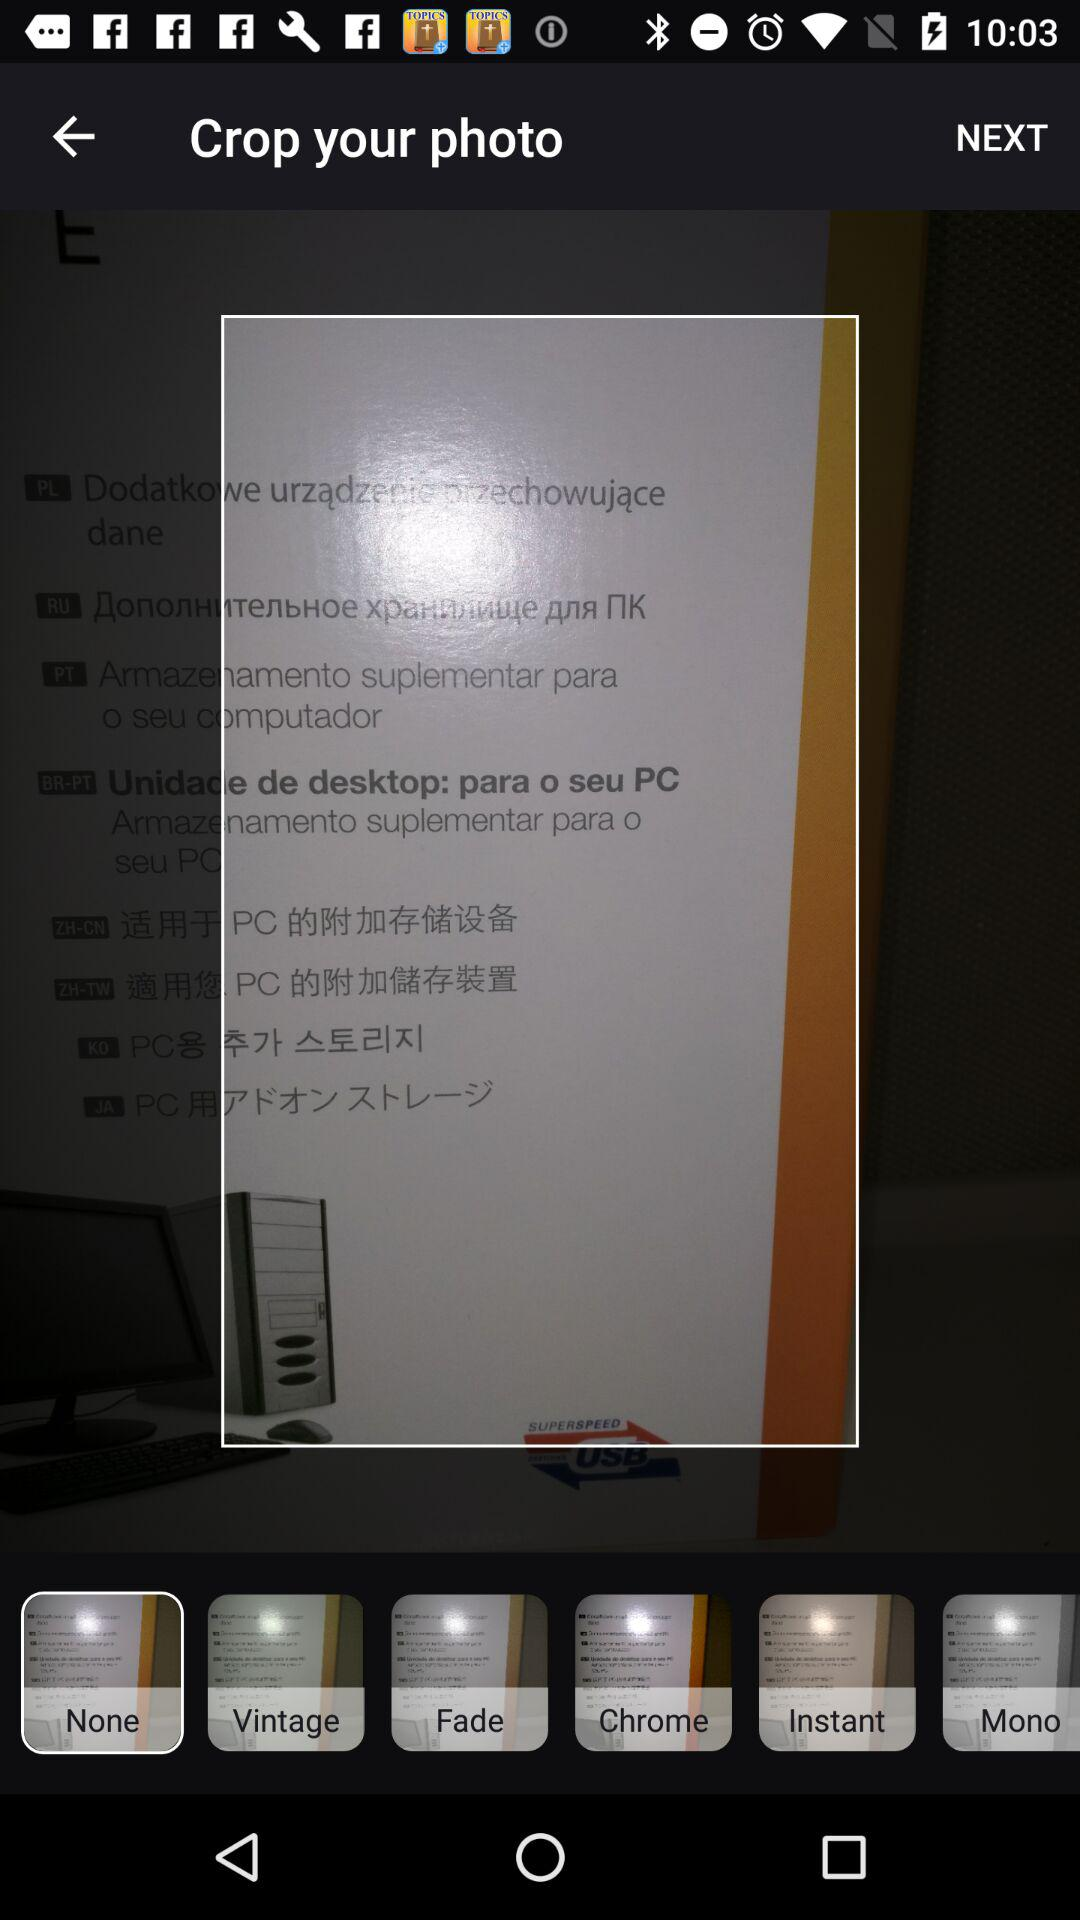How many filters are available?
Answer the question using a single word or phrase. 6 